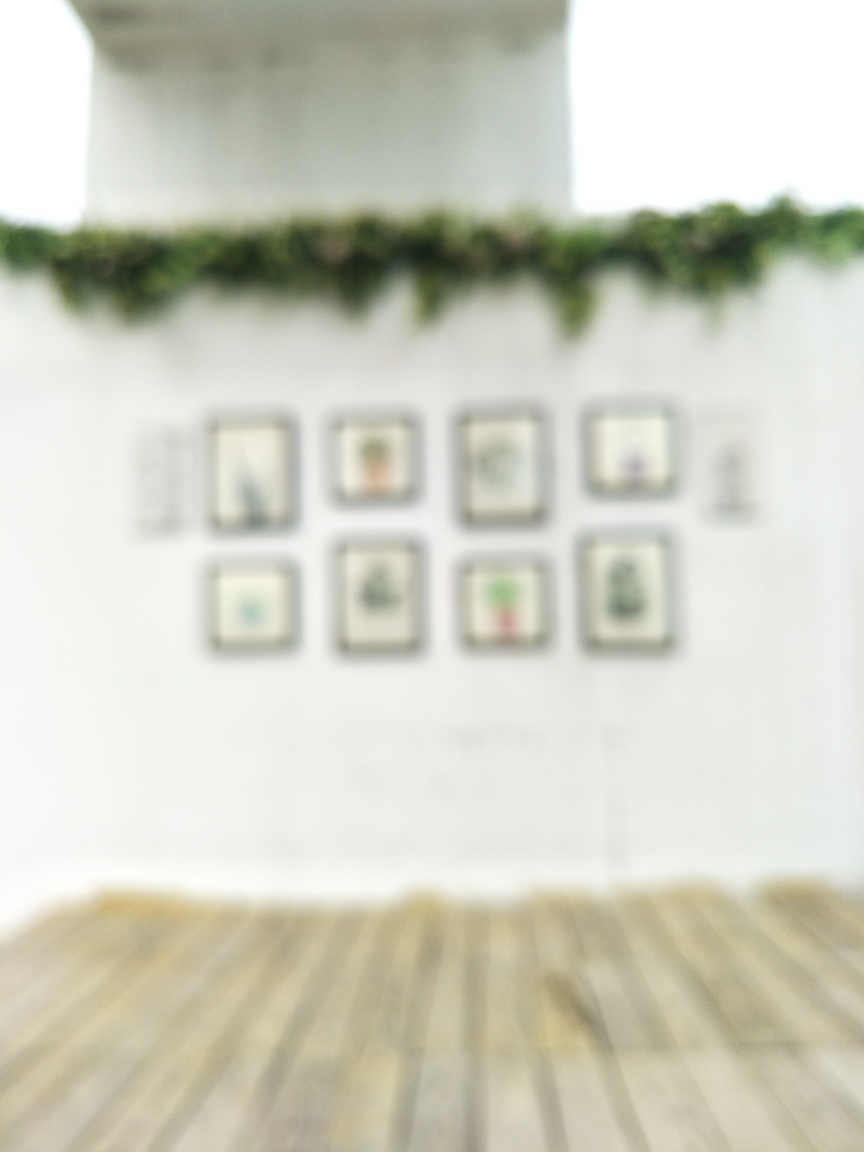Can you comment on the general ambiance or mood that the blurry state of the image evokes? The lack of clarity in the image creates an atmosphere of mystery and abstraction. The blurriness softens the space and imparts a dreamlike quality, inviting the viewer to interpret the scene through their imagination rather than through crisp detail. 